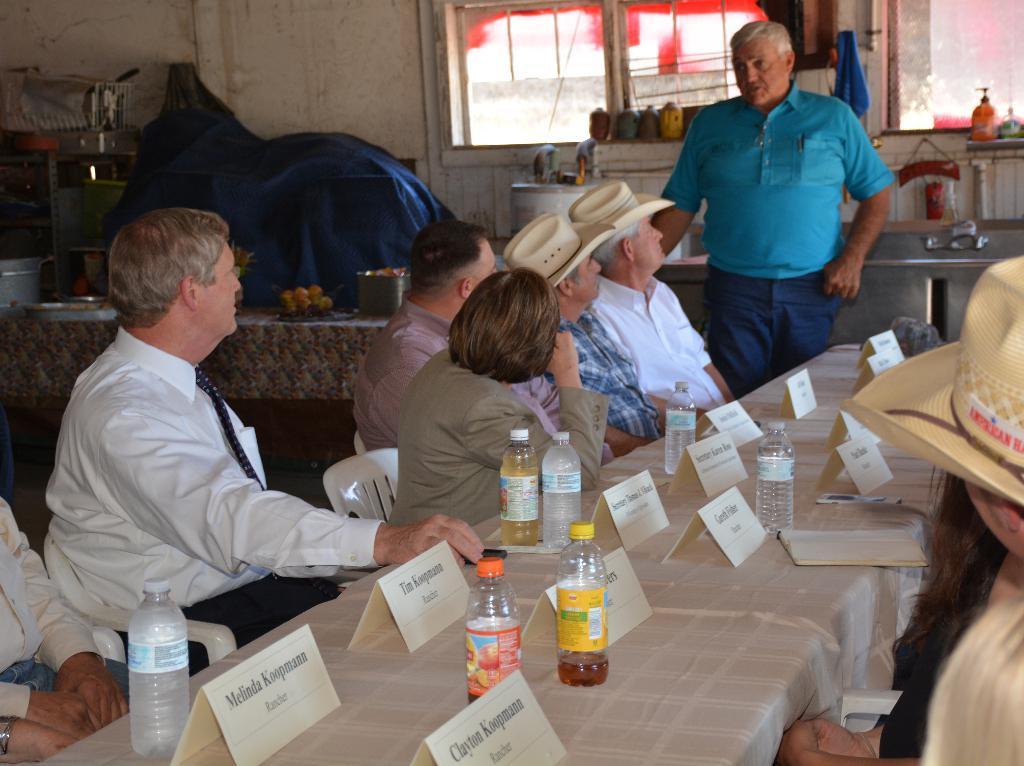Please provide a concise description of this image. There are few people sitting on the chair at the table. On the table there are water bottles and a book. In the background there is a wall,window,sink and fruits on a table. 